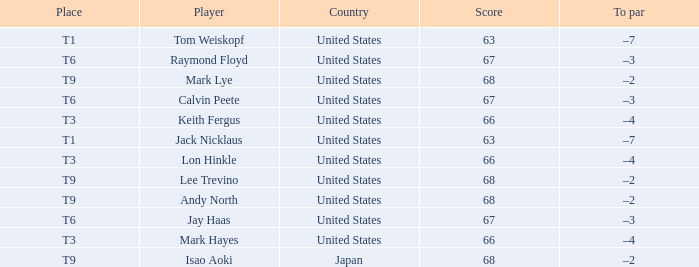Could you parse the entire table as a dict? {'header': ['Place', 'Player', 'Country', 'Score', 'To par'], 'rows': [['T1', 'Tom Weiskopf', 'United States', '63', '–7'], ['T6', 'Raymond Floyd', 'United States', '67', '–3'], ['T9', 'Mark Lye', 'United States', '68', '–2'], ['T6', 'Calvin Peete', 'United States', '67', '–3'], ['T3', 'Keith Fergus', 'United States', '66', '–4'], ['T1', 'Jack Nicklaus', 'United States', '63', '–7'], ['T3', 'Lon Hinkle', 'United States', '66', '–4'], ['T9', 'Lee Trevino', 'United States', '68', '–2'], ['T9', 'Andy North', 'United States', '68', '–2'], ['T6', 'Jay Haas', 'United States', '67', '–3'], ['T3', 'Mark Hayes', 'United States', '66', '–4'], ['T9', 'Isao Aoki', 'Japan', '68', '–2']]} What is the total number of Score, when Country is "United States", and when Player is "Lee Trevino"? 1.0. 